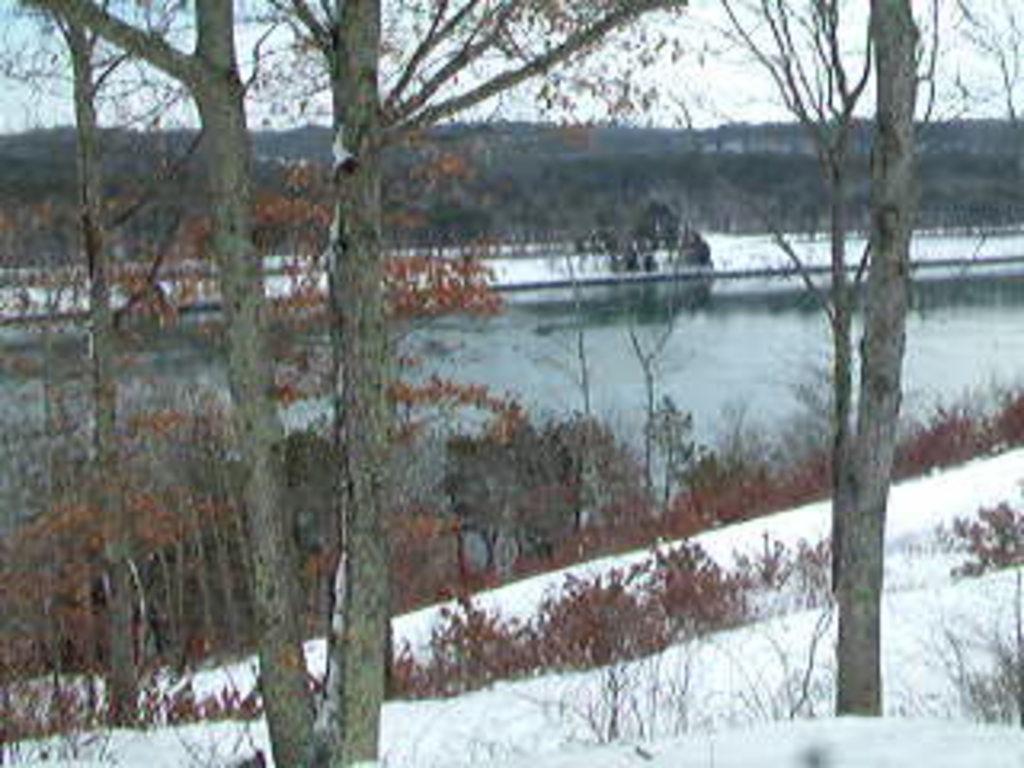Can you describe this image briefly? In this picture I can see water, trees and plants. I can also see snow. In the background I can see the sky. 